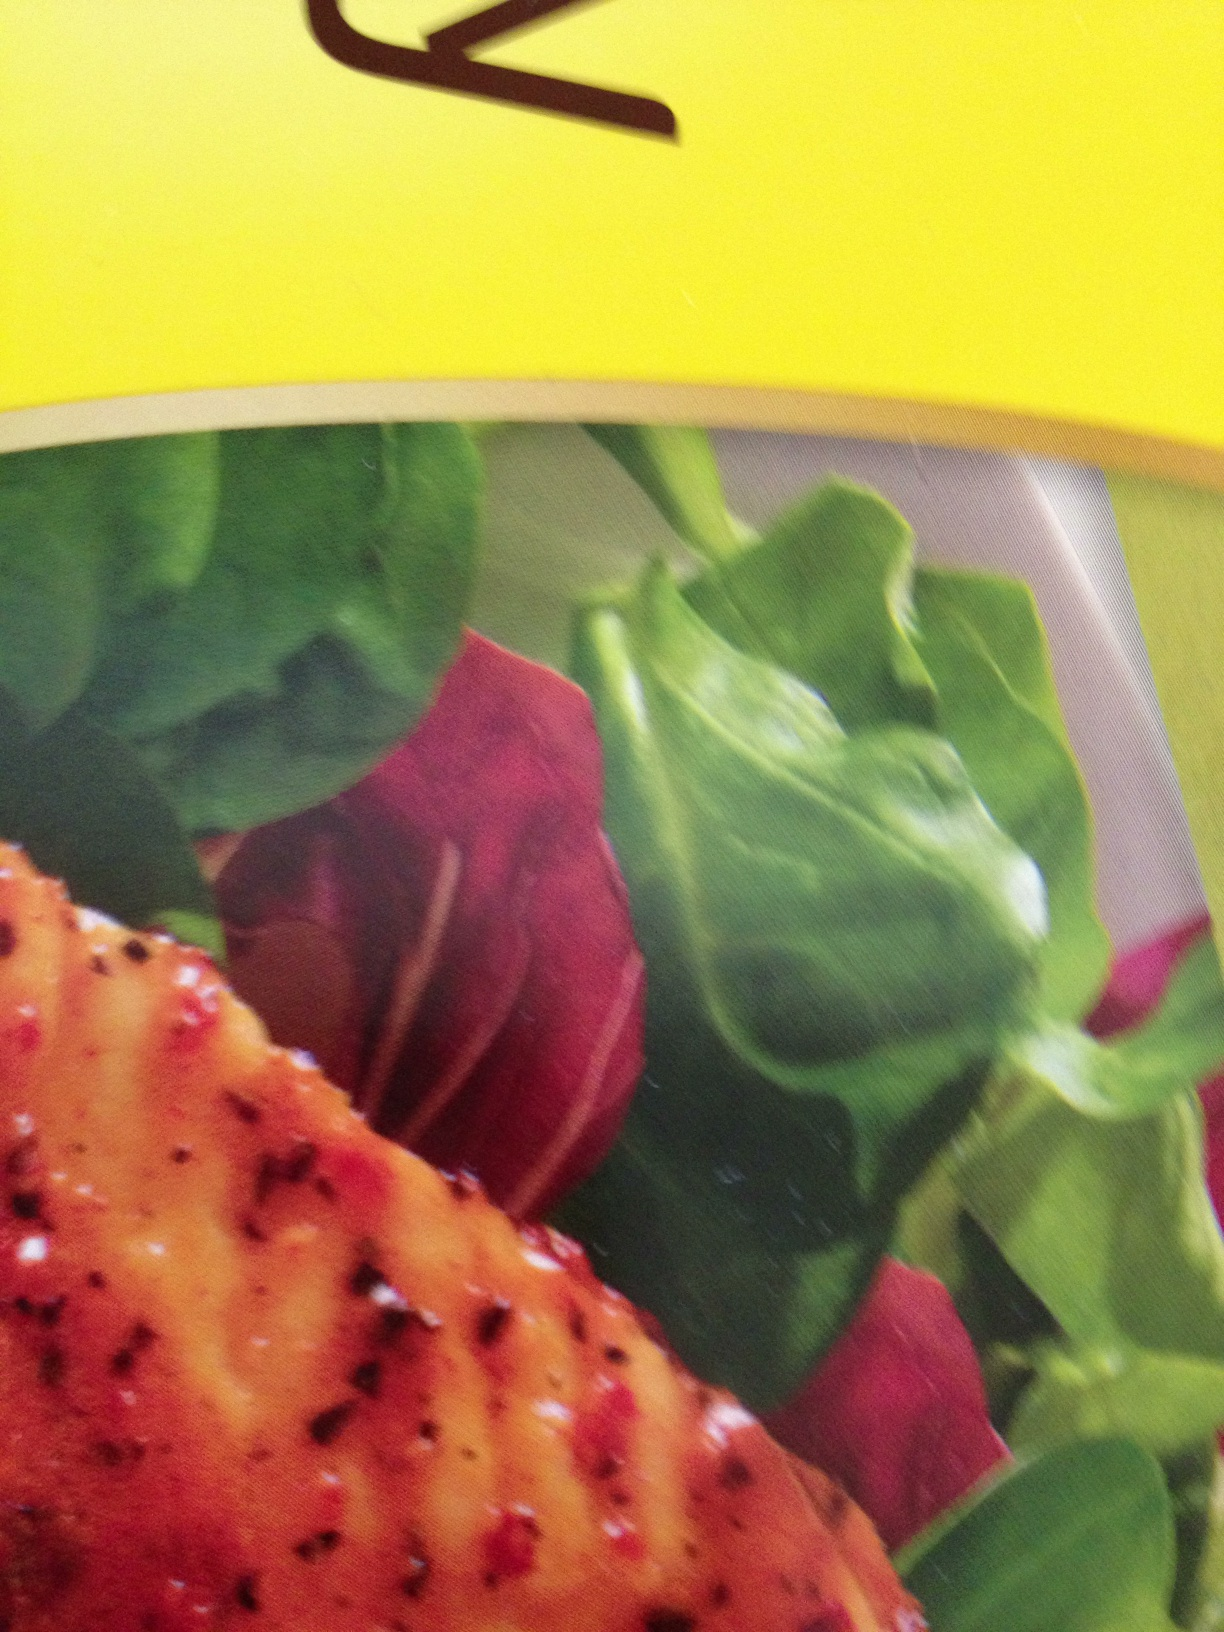What kind of event or meal would this dish be suitable for? This dish would be perfect for a casual yet elegant dinner gathering or a weekend brunch. Its balance of hearty protein and fresh vegetables makes it versatile enough to be enjoyed in a variety of settings, offering both nutrition and gourmet appeal. 